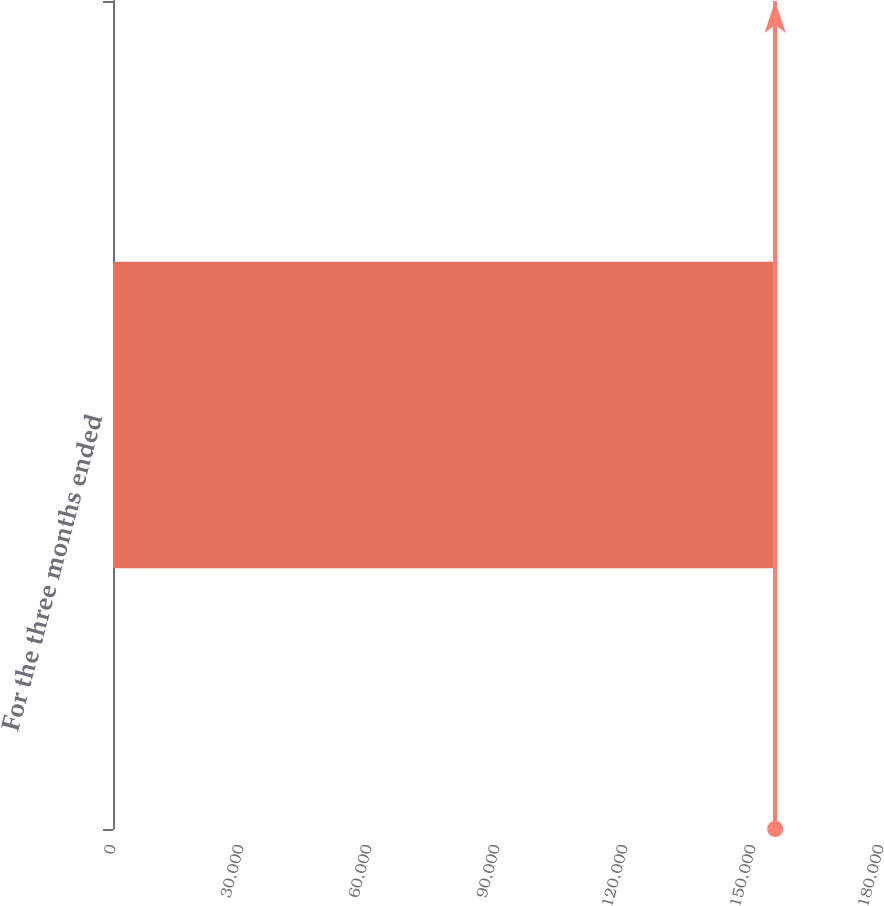Convert chart to OTSL. <chart><loc_0><loc_0><loc_500><loc_500><bar_chart><fcel>For the three months ended<nl><fcel>155198<nl></chart> 